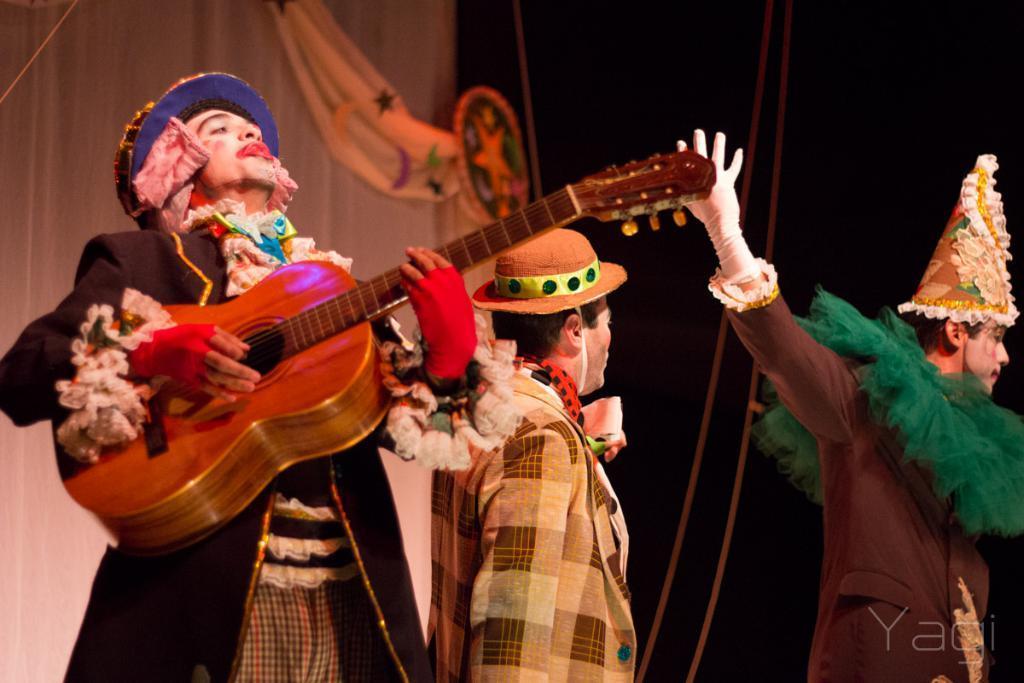Please provide a concise description of this image. The picture there are three people wearing a joker costume and one of the person is playing a guitar and behind the three people there are two curtains. 